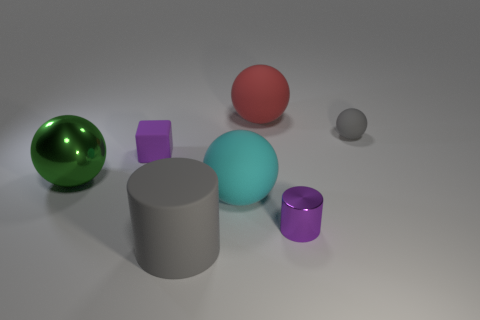Subtract 1 spheres. How many spheres are left? 3 Subtract all big balls. How many balls are left? 1 Add 2 yellow shiny balls. How many objects exist? 9 Subtract all red spheres. How many spheres are left? 3 Subtract all blue balls. Subtract all green blocks. How many balls are left? 4 Subtract all spheres. How many objects are left? 3 Subtract all blue matte balls. Subtract all tiny purple matte cubes. How many objects are left? 6 Add 6 rubber balls. How many rubber balls are left? 9 Add 6 metal things. How many metal things exist? 8 Subtract 1 purple cubes. How many objects are left? 6 